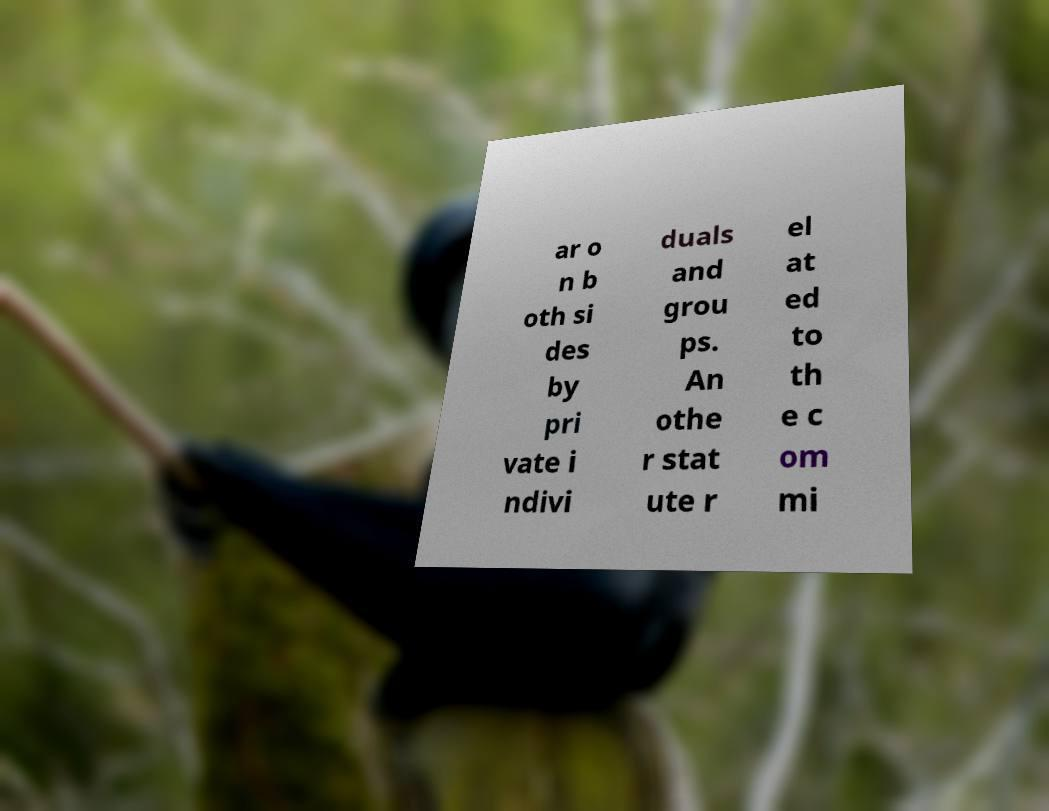What messages or text are displayed in this image? I need them in a readable, typed format. ar o n b oth si des by pri vate i ndivi duals and grou ps. An othe r stat ute r el at ed to th e c om mi 